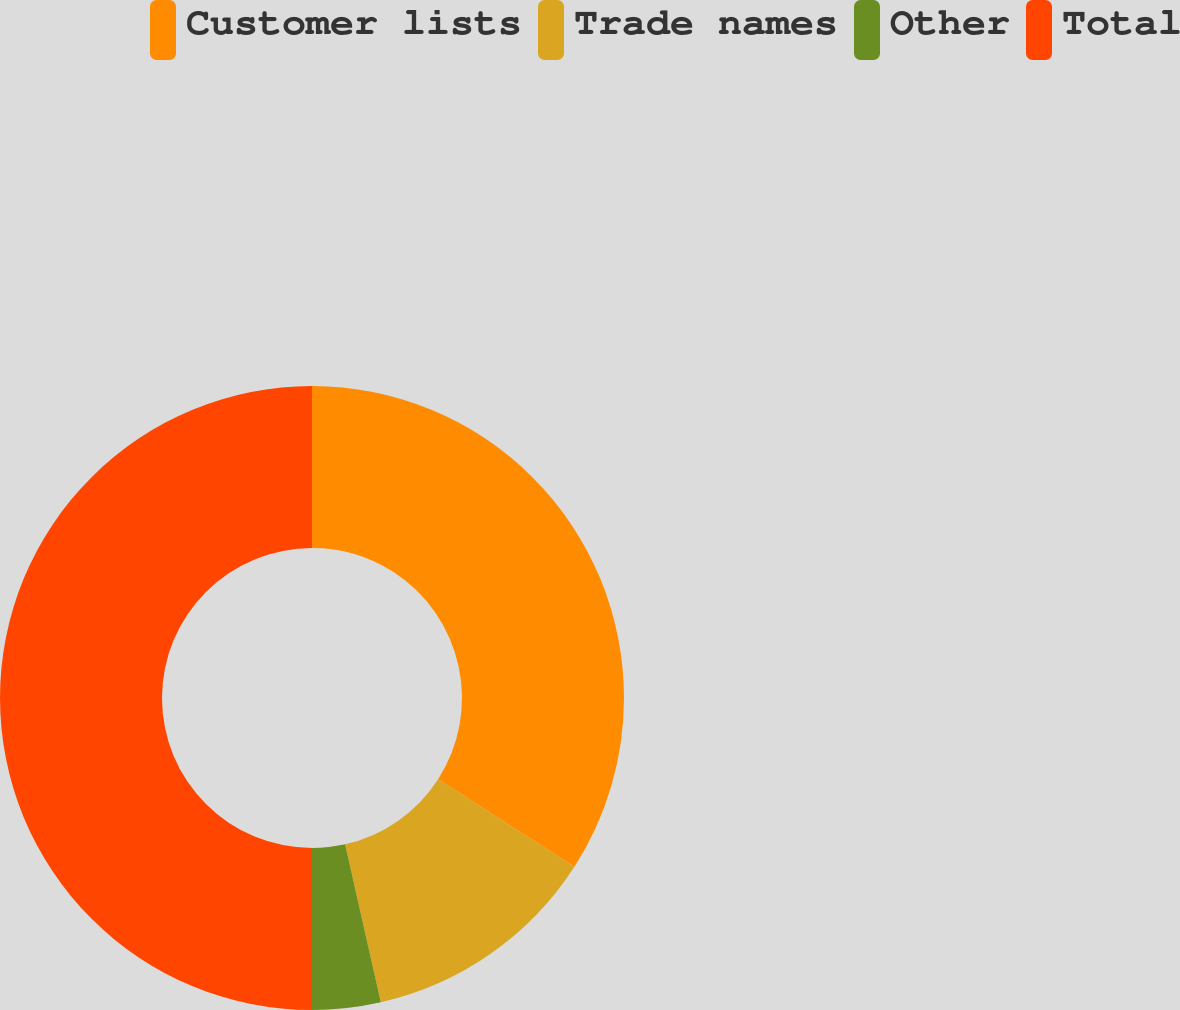Convert chart. <chart><loc_0><loc_0><loc_500><loc_500><pie_chart><fcel>Customer lists<fcel>Trade names<fcel>Other<fcel>Total<nl><fcel>34.1%<fcel>12.36%<fcel>3.54%<fcel>50.0%<nl></chart> 